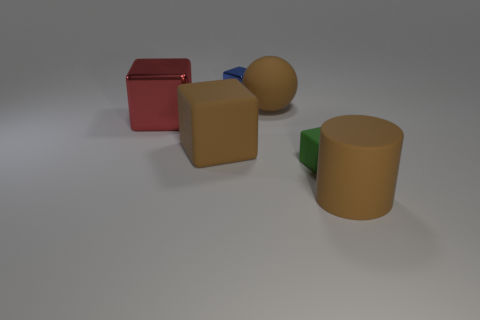Add 1 red rubber objects. How many objects exist? 7 Subtract all spheres. How many objects are left? 5 Subtract 0 green cylinders. How many objects are left? 6 Subtract all brown matte cylinders. Subtract all blue rubber cylinders. How many objects are left? 5 Add 5 brown rubber balls. How many brown rubber balls are left? 6 Add 2 cubes. How many cubes exist? 6 